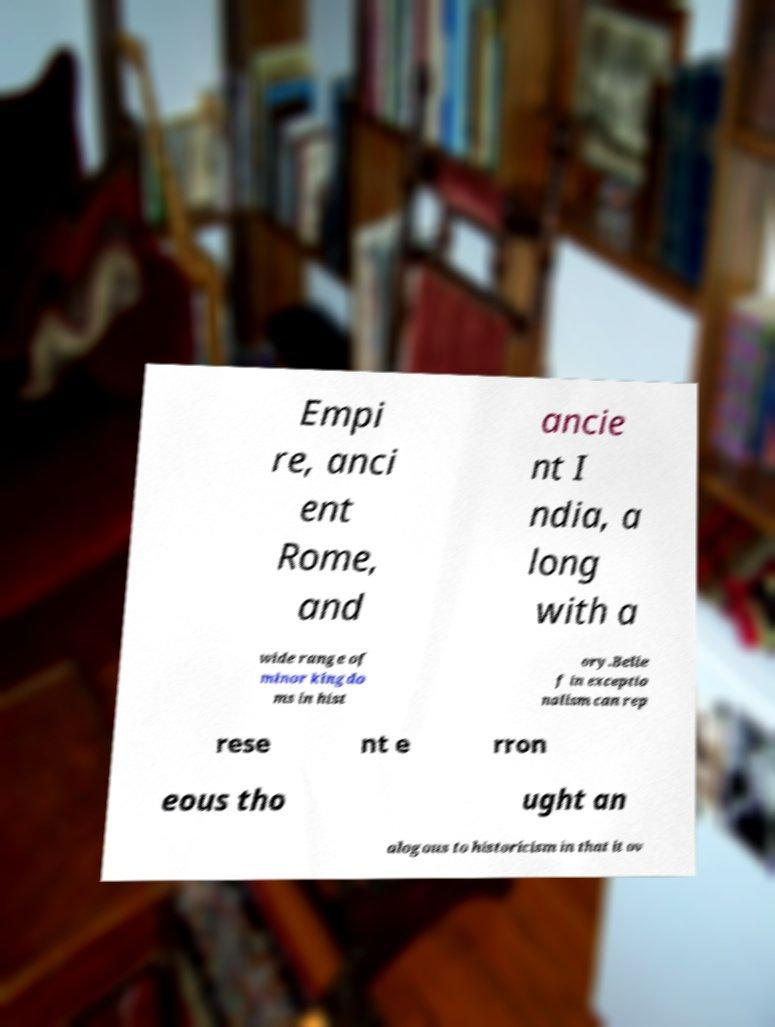Please identify and transcribe the text found in this image. Empi re, anci ent Rome, and ancie nt I ndia, a long with a wide range of minor kingdo ms in hist ory.Belie f in exceptio nalism can rep rese nt e rron eous tho ught an alogous to historicism in that it ov 